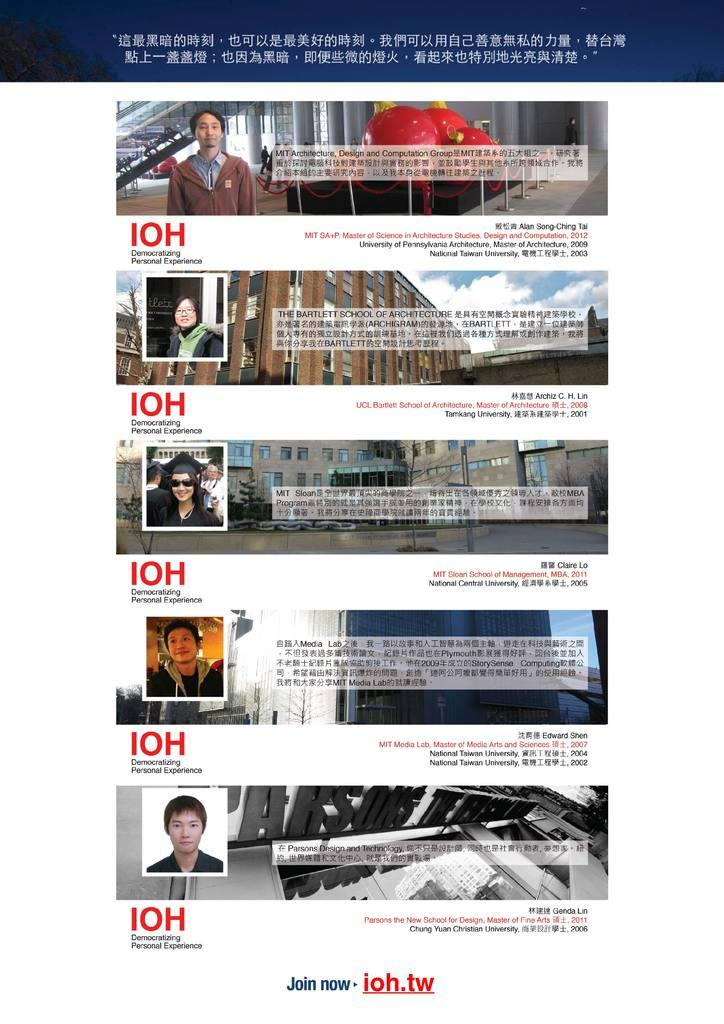How many people are in the image? There are persons in the image, but the exact number cannot be determined from the provided facts. What is written beside the persons? There is writing beside the persons in the image. Can you describe the background of the image? There are other objects in the background of the image. What type of cough can be heard from the person in the image? There is no indication of any sound, including a cough, in the image. How many mice are visible in the image? There is no mention of mice in the image, so it is impossible to determine their presence or quantity. 